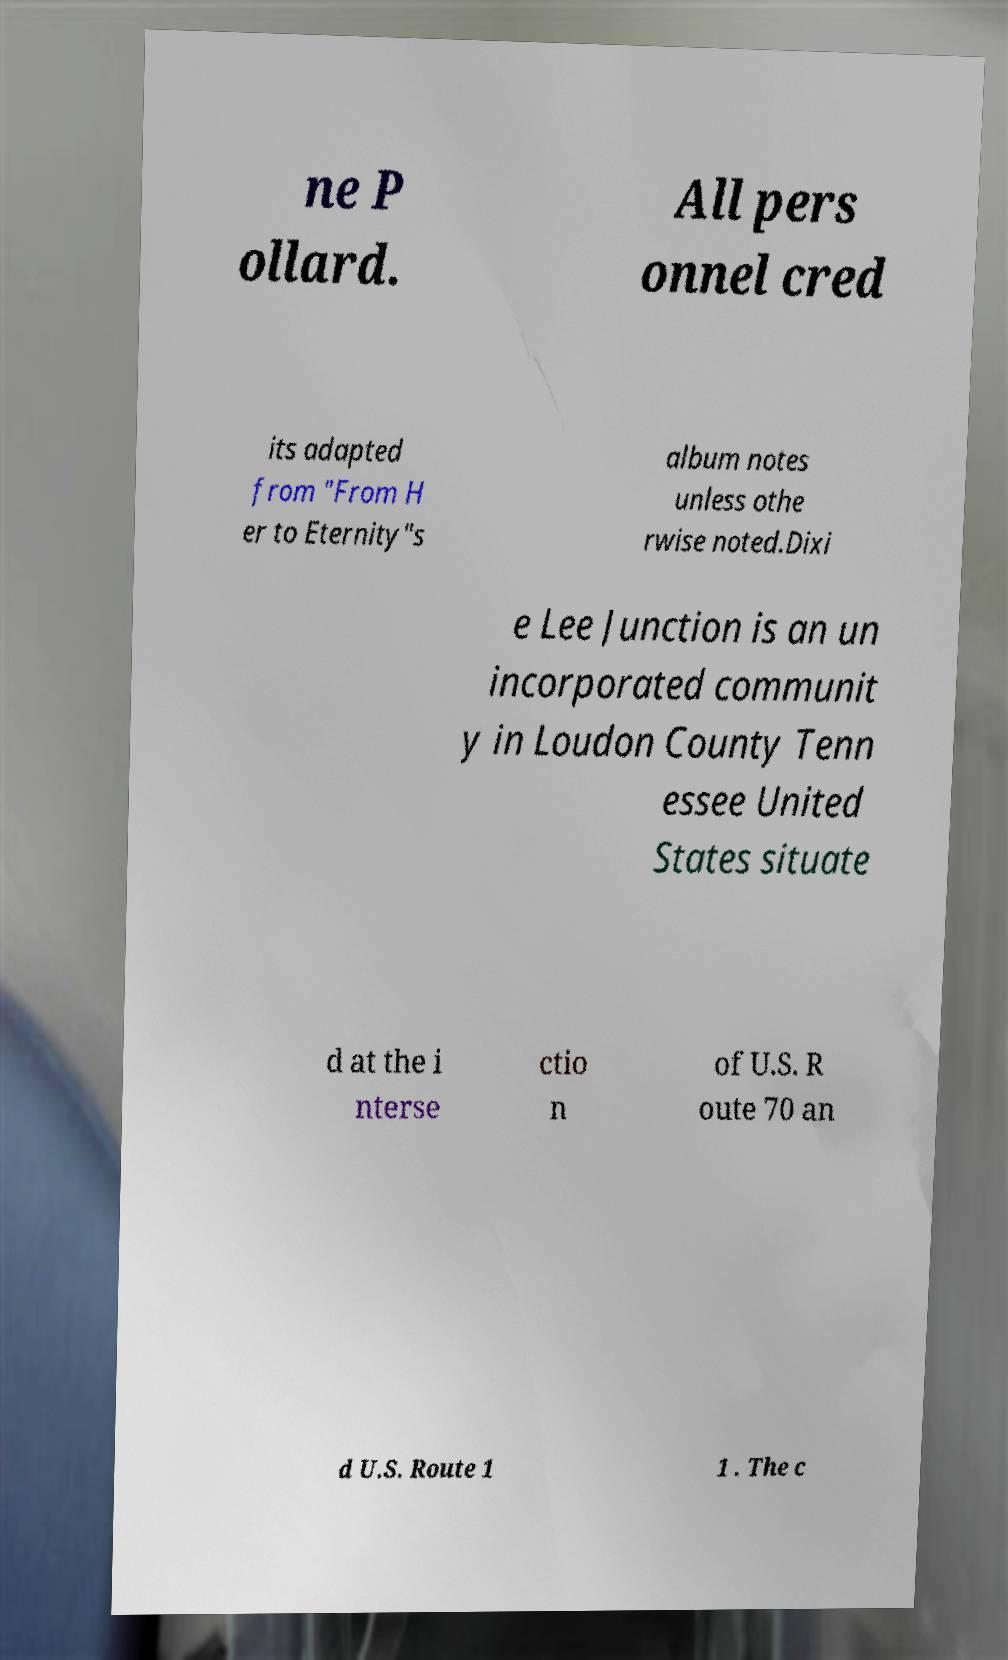There's text embedded in this image that I need extracted. Can you transcribe it verbatim? ne P ollard. All pers onnel cred its adapted from "From H er to Eternity"s album notes unless othe rwise noted.Dixi e Lee Junction is an un incorporated communit y in Loudon County Tenn essee United States situate d at the i nterse ctio n of U.S. R oute 70 an d U.S. Route 1 1 . The c 